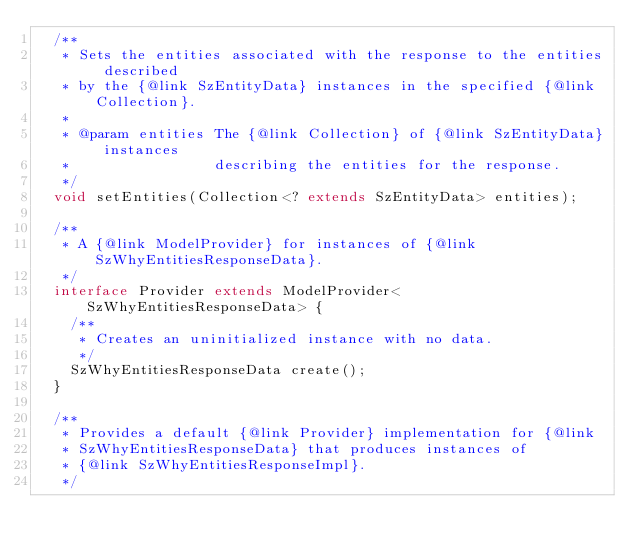Convert code to text. <code><loc_0><loc_0><loc_500><loc_500><_Java_>  /**
   * Sets the entities associated with the response to the entities described
   * by the {@link SzEntityData} instances in the specified {@link Collection}.
   *
   * @param entities The {@link Collection} of {@link SzEntityData} instances
   *                 describing the entities for the response.
   */
  void setEntities(Collection<? extends SzEntityData> entities);

  /**
   * A {@link ModelProvider} for instances of {@link SzWhyEntitiesResponseData}.
   */
  interface Provider extends ModelProvider<SzWhyEntitiesResponseData> {
    /**
     * Creates an uninitialized instance with no data.
     */
    SzWhyEntitiesResponseData create();
  }

  /**
   * Provides a default {@link Provider} implementation for {@link
   * SzWhyEntitiesResponseData} that produces instances of
   * {@link SzWhyEntitiesResponseImpl}.
   */</code> 